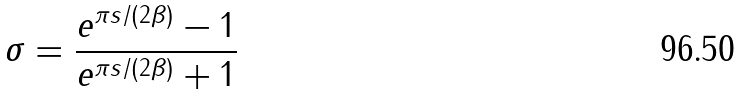<formula> <loc_0><loc_0><loc_500><loc_500>\sigma = \frac { e ^ { \pi s / ( 2 \beta ) } - 1 } { e ^ { \pi s / ( 2 \beta ) } + 1 }</formula> 